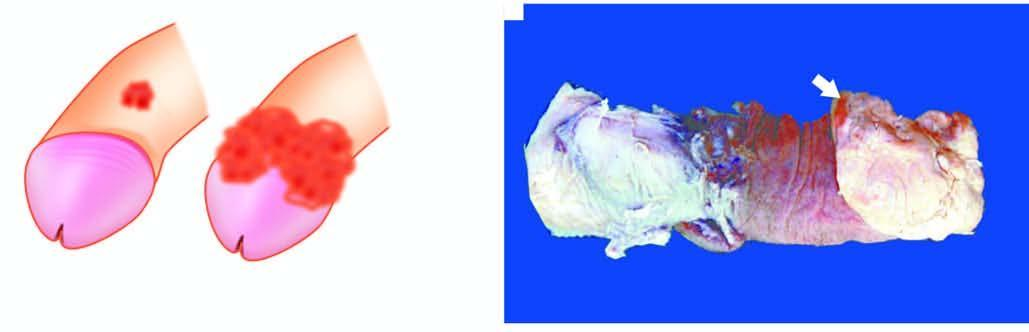what does amputated specimen of the penis show?
Answer the question using a single word or phrase. A cauliflower growth on the coronal sulcus 